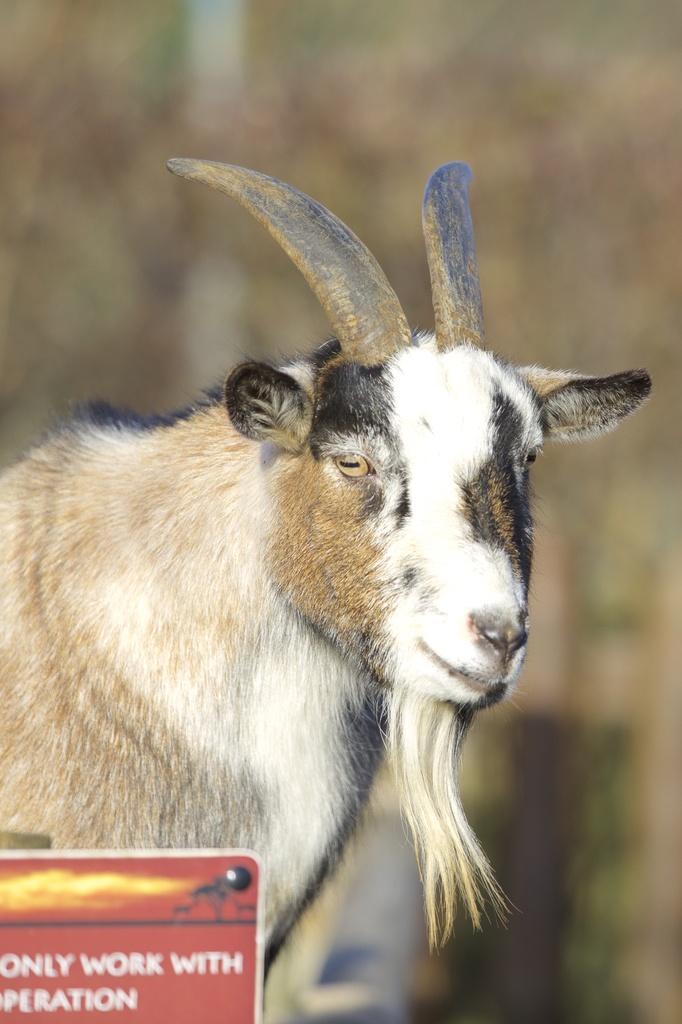Describe this image in one or two sentences. In the picture we can see a photograph of a goat which is with horns and some part of it is white in color and some part is black in color. 